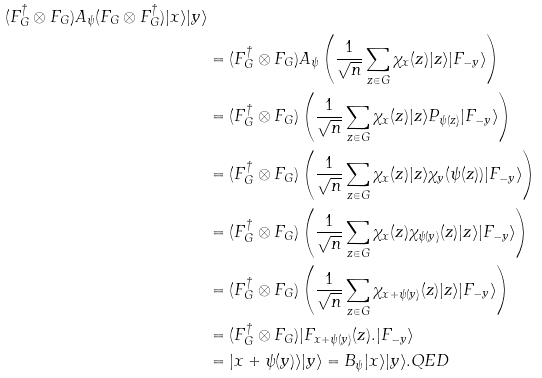<formula> <loc_0><loc_0><loc_500><loc_500>( F _ { G } ^ { \dagger } \otimes F _ { G } ) A _ { \psi } ( F _ { G } \otimes F _ { G } ^ { \dagger } ) | x \rangle | y \rangle \\ & = ( F _ { G } ^ { \dagger } \otimes F _ { G } ) A _ { \psi } \left ( \frac { 1 } { \sqrt { n } } \sum _ { z \in G } \chi _ { x } ( z ) | z \rangle | F _ { - y } \rangle \right ) \\ & = ( F _ { G } ^ { \dagger } \otimes F _ { G } ) \left ( \frac { 1 } { \sqrt { n } } \sum _ { z \in G } \chi _ { x } ( z ) | z \rangle P _ { \psi ( z ) } | F _ { - y } \rangle \right ) \\ & = ( F _ { G } ^ { \dagger } \otimes F _ { G } ) \left ( \frac { 1 } { \sqrt { n } } \sum _ { z \in G } \chi _ { x } ( z ) | z \rangle \chi _ { y } ( \psi ( z ) ) | F _ { - y } \rangle \right ) \\ & = ( F _ { G } ^ { \dagger } \otimes F _ { G } ) \left ( \frac { 1 } { \sqrt { n } } \sum _ { z \in G } \chi _ { x } ( z ) \chi _ { \psi ( y ) } ( z ) | z \rangle | F _ { - y } \rangle \right ) \\ & = ( F _ { G } ^ { \dagger } \otimes F _ { G } ) \left ( \frac { 1 } { \sqrt { n } } \sum _ { z \in G } \chi _ { x + \psi ( y ) } ( z ) | z \rangle | F _ { - y } \rangle \right ) \\ & = ( F _ { G } ^ { \dagger } \otimes F _ { G } ) | F _ { x + \psi ( y ) } ( z ) . | F _ { - y } \rangle \\ & = | x + \psi ( y ) \rangle | y \rangle = B _ { \psi } | x \rangle | y \rangle . Q E D</formula> 